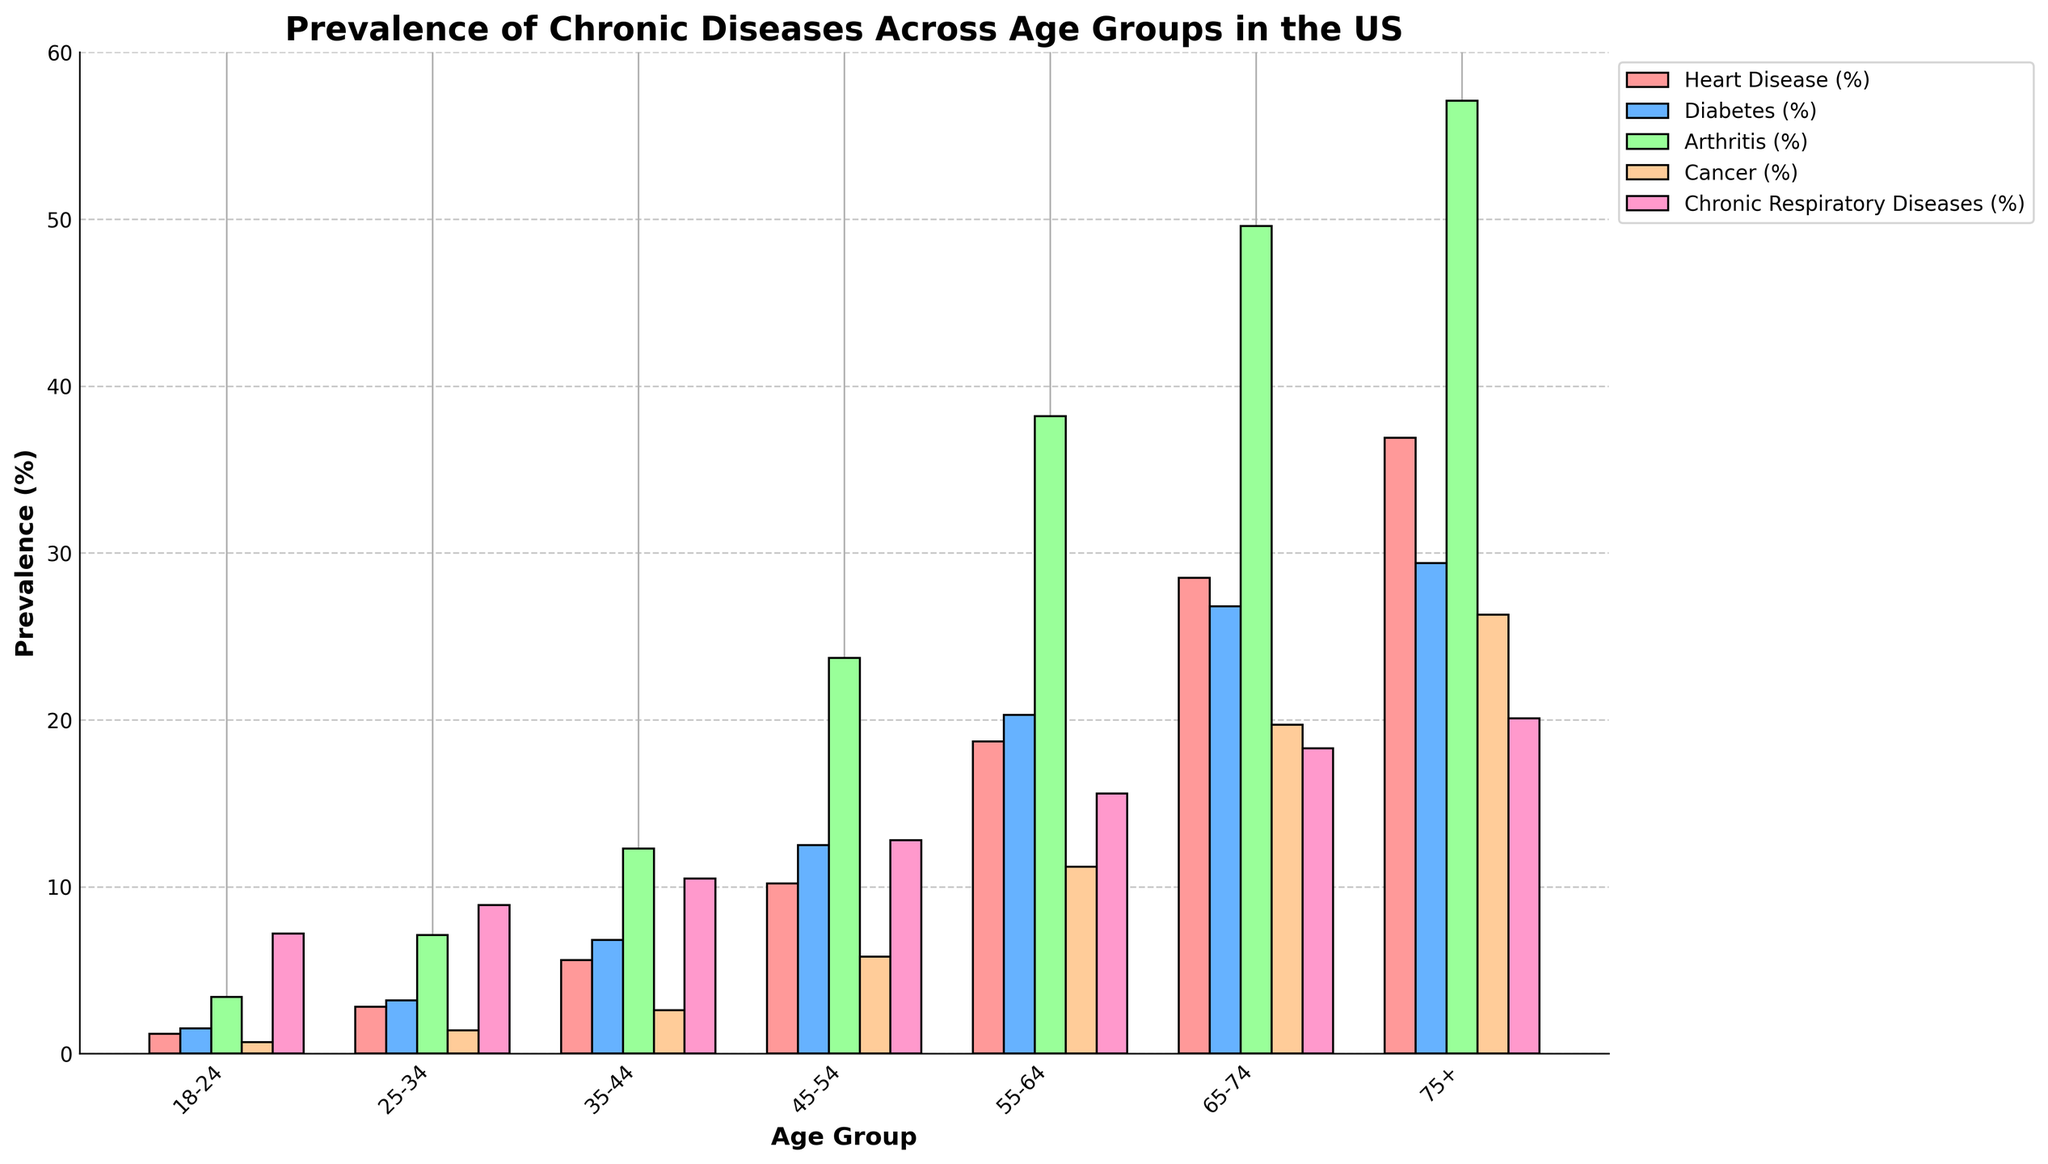What age group has the highest prevalence of heart disease? By examining the height of the bars corresponding to heart disease across all age groups, the tallest bar represents the age group with the highest prevalence. For heart disease, the tallest bar is for the 75+ age group.
Answer: 75+ Which chronic disease has the highest prevalence in the 55-64 age group? To determine this, look at the bars for each disease in the 55-64 age group. The highest bar among them indicates the disease with the highest prevalence. For the 55-64 age group, arthritis has the highest bar.
Answer: Arthritis What is the difference in the prevalence of diabetes between age groups 45-54 and 65-74? Check the heights of the diabetes bars for both 45-54 and 65-74 age groups. The prevalence for 45-54 is 12.5%, and for 65-74, it is 26.8%. Calculate the difference: 26.8% - 12.5% = 14.3%.
Answer: 14.3% How does the prevalence of cancer change from the 25-34 age group to the 55-64 age group? Compare the bars representing cancer prevalence in both age groups. For 25-34, the prevalence is 1.4%, and for 55-64, it is 11.2%. Determine the change by subtracting the smaller value from the larger value: 11.2% - 1.4% = 9.8%.
Answer: Increases by 9.8% Which disease shows the smallest increase in prevalence from the 18-24 age group to the 75+ age group? Compare the change in bar heights for each disease from the 18-24 age group to the 75+ age group. Calculate the difference for each: Heart Disease (36.9% - 1.2% = 35.7%), Diabetes (29.4% - 1.5% = 27.9%), Arthritis (57.1% - 3.4% = 53.7%), Cancer (26.3% - 0.7% = 25.6%), Chronic Respiratory Diseases (20.1% - 7.2% = 12.9%). The smallest increase is for chronic respiratory diseases.
Answer: Chronic Respiratory Diseases What is the average prevalence of arthritis across all age groups? Add the prevalence values of arthritis for all age groups (3.4 + 7.1 + 12.3 + 23.7 + 38.2 + 49.6 + 57.1) and divide by the number of age groups (7): (3.4 + 7.1 + 12.3 + 23.7 + 38.2 + 49.6 + 57.1) / 7 = 27.2%.
Answer: 27.2% Which age group has a higher prevalence of diabetes: 35-44 or 45-54? Compare the bar heights for diabetes in the 35-44 and 45-54 age groups. The prevalence for 35-44 is 6.8%, and for 45-54, it is 12.5%. 12.5% is greater than 6.8%.
Answer: 45-54 What is the combined prevalence of heart disease and cancer in the 65-74 age group? Add the prevalence values for heart disease and cancer in the 65-74 age group. Heart disease is 28.5%, and cancer is 19.7%. Combined prevalence: 28.5% + 19.7% = 48.2%.
Answer: 48.2% How does the prevalence of chronic respiratory diseases in the 18-24 age group compare to the 75+ age group? Examine the heights of the bars for chronic respiratory diseases in both age groups. The prevalence for 18-24 is 7.2% and for 75+, it is 20.1%. 20.1% is greater than 7.2%.
Answer: 75+ age group has higher prevalence What is the range of prevalence values for heart disease across all age groups? Identify the minimum and maximum prevalence values for heart disease across all age groups. The minimum is 1.2% (18-24) and the maximum is 36.9% (75+). Calculate the range: 36.9% - 1.2% = 35.7%.
Answer: 35.7% 